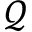Convert formula to latex. <formula><loc_0><loc_0><loc_500><loc_500>\mathcal { Q }</formula> 